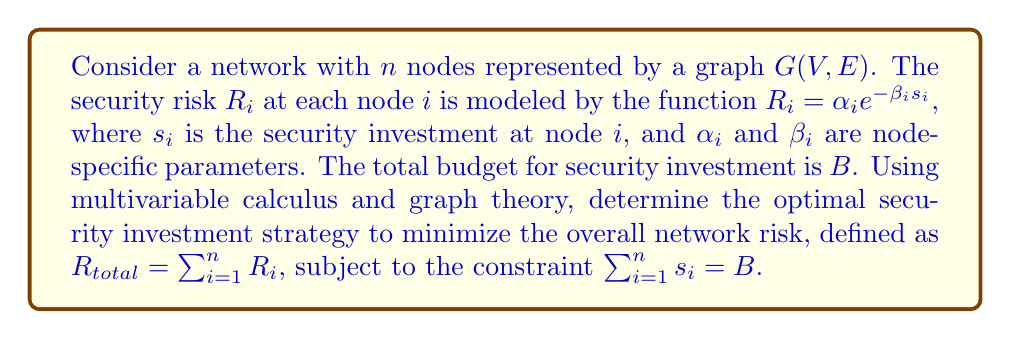Can you solve this math problem? To solve this optimization problem, we'll use the method of Lagrange multipliers:

1) Form the Lagrangian function:
   $$L(s_1, ..., s_n, \lambda) = \sum_{i=1}^n \alpha_i e^{-\beta_i s_i} + \lambda(\sum_{i=1}^n s_i - B)$$

2) Take partial derivatives with respect to each $s_i$ and $\lambda$:
   $$\frac{\partial L}{\partial s_i} = -\alpha_i \beta_i e^{-\beta_i s_i} + \lambda = 0$$
   $$\frac{\partial L}{\partial \lambda} = \sum_{i=1}^n s_i - B = 0$$

3) From the first equation:
   $$\lambda = \alpha_i \beta_i e^{-\beta_i s_i}$$

4) Taking the natural log of both sides:
   $$\ln(\lambda) = \ln(\alpha_i) + \ln(\beta_i) - \beta_i s_i$$

5) Solving for $s_i$:
   $$s_i = \frac{\ln(\alpha_i) + \ln(\beta_i) - \ln(\lambda)}{\beta_i}$$

6) Substitute this into the constraint equation:
   $$\sum_{i=1}^n \frac{\ln(\alpha_i) + \ln(\beta_i) - \ln(\lambda)}{\beta_i} = B$$

7) Solve for $\lambda$:
   $$\lambda = e^{\frac{\sum_{i=1}^n \frac{\ln(\alpha_i) + \ln(\beta_i)}{\beta_i} - B}{\sum_{i=1}^n \frac{1}{\beta_i}}}$$

8) The optimal investment for each node is:
   $$s_i^* = \frac{\ln(\alpha_i) + \ln(\beta_i) - \ln(\lambda)}{\beta_i}$$

This solution minimizes the overall network risk while satisfying the budget constraint. The graph structure affects the risk through the node-specific parameters $\alpha_i$ and $\beta_i$, which could be influenced by factors such as node degree or centrality measures.
Answer: $s_i^* = \frac{\ln(\alpha_i) + \ln(\beta_i) - \ln(\lambda)}{\beta_i}$, where $\lambda = e^{\frac{\sum_{i=1}^n \frac{\ln(\alpha_i) + \ln(\beta_i)}{\beta_i} - B}{\sum_{i=1}^n \frac{1}{\beta_i}}}$ 